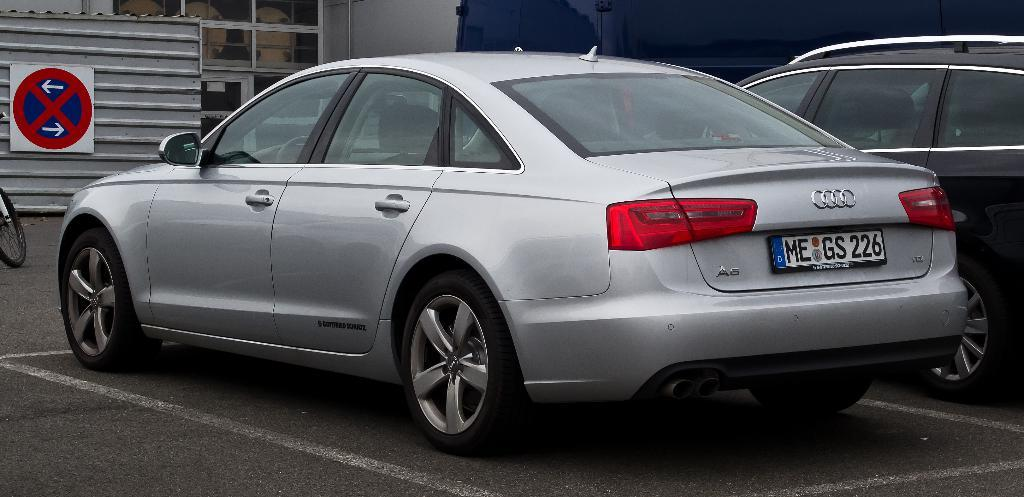Provide a one-sentence caption for the provided image. A parked car with the license plate number MEGS226. 